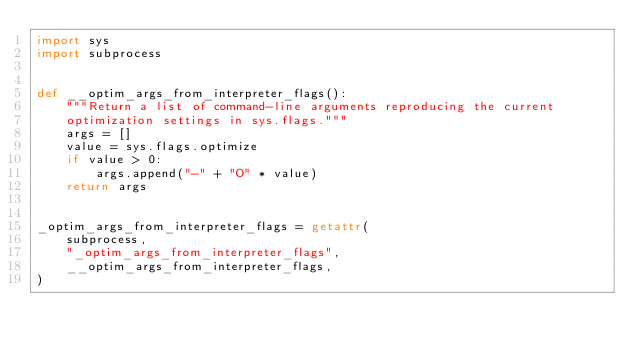<code> <loc_0><loc_0><loc_500><loc_500><_Python_>import sys
import subprocess


def __optim_args_from_interpreter_flags():
    """Return a list of command-line arguments reproducing the current
    optimization settings in sys.flags."""
    args = []
    value = sys.flags.optimize
    if value > 0:
        args.append("-" + "O" * value)
    return args


_optim_args_from_interpreter_flags = getattr(
    subprocess,
    "_optim_args_from_interpreter_flags",
    __optim_args_from_interpreter_flags,
)
</code> 